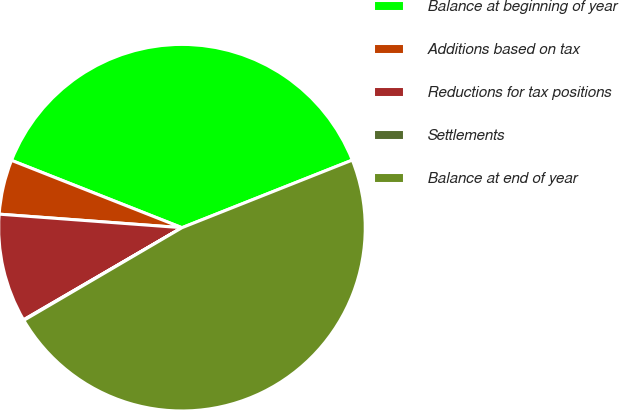Convert chart. <chart><loc_0><loc_0><loc_500><loc_500><pie_chart><fcel>Balance at beginning of year<fcel>Additions based on tax<fcel>Reductions for tax positions<fcel>Settlements<fcel>Balance at end of year<nl><fcel>38.0%<fcel>4.81%<fcel>9.56%<fcel>0.05%<fcel>47.58%<nl></chart> 